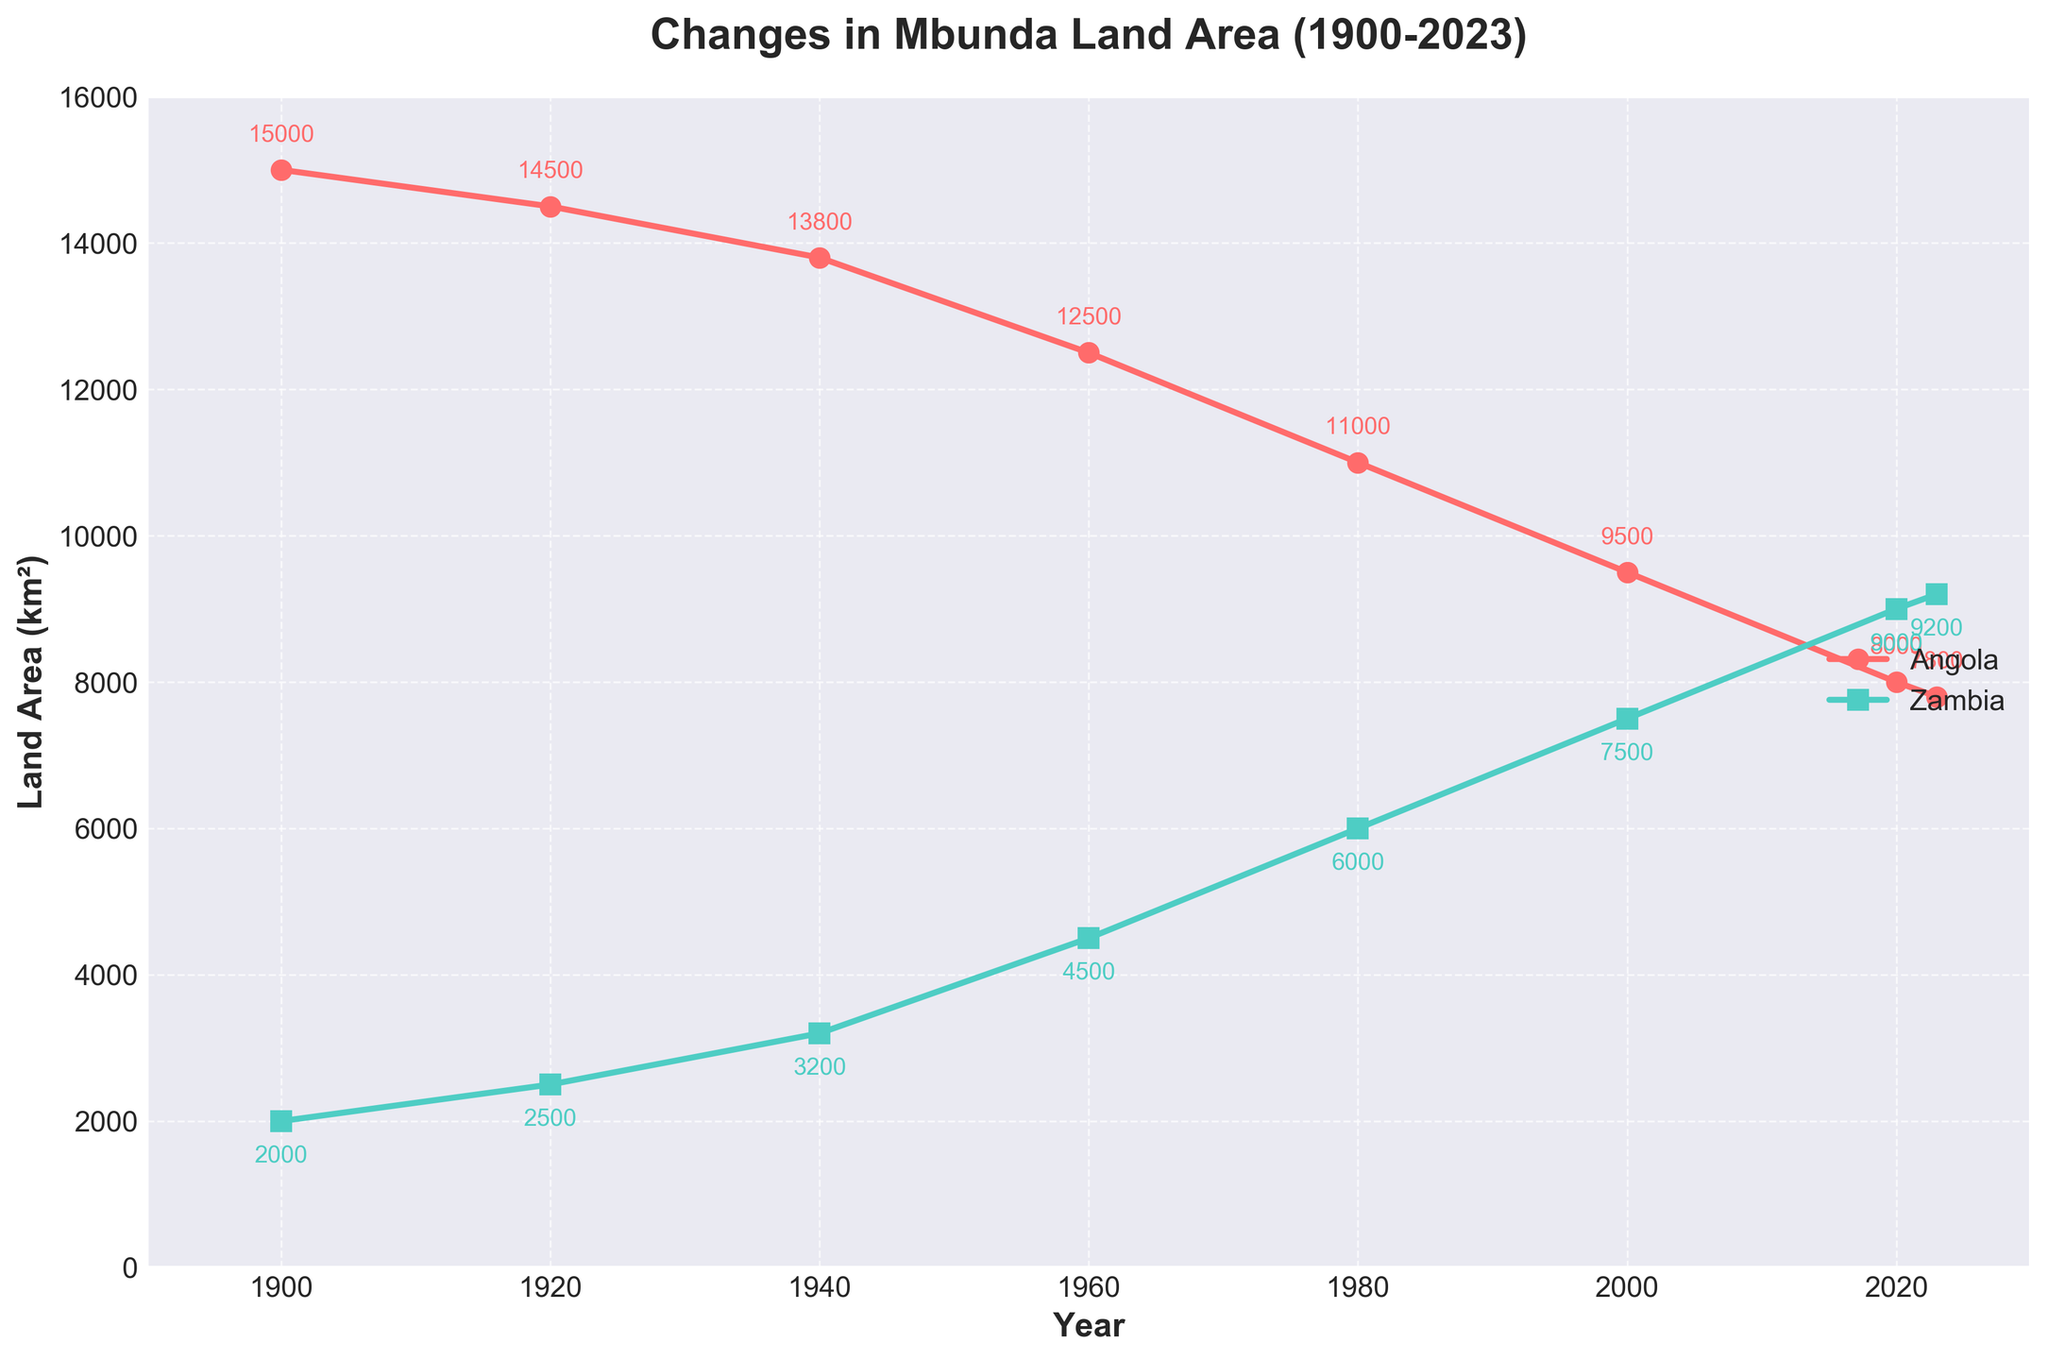What was the land area occupied by Mbunda communities in Angola in 1900? Look at the y-axis for the land area corresponding to the year 1900 along the x-axis for Angola's line (red).
Answer: 15,000 km² What trend do you observe for the land area occupied by the Mbunda community in Zambia from 1900 to 2023? Observe the green line on the plot from 1900 to 2023. It shows a consistent increase over time.
Answer: Increasing Which year did Angola's Mbunda community have a land area of 11,000 km²? Track the red line and find the point where it intersects with the 11,000 km² mark on the y-axis.
Answer: 1980 What is the difference in land area occupied by the Mbunda communities in Zambia between the years 1960 and 1980? On the green line, find the land areas for the years 1960 and 1980 and subtract the 1960 value from the 1980 value. 4500 km² and 6000 km² respectively. Thus, 6000 - 4500 = 1500.
Answer: 1,500 km² In which year did the Mbunda communities in Zambia first occupy a larger area than those in Angola? Compare the values of both lines (red and green) across years. Find the first year where the green line is above the red line.
Answer: 2020 How much land area did Mbunda communities lose in Angola from 1940 to 1980? For Angola, note the land areas from the red line at 1940 and 1980. Then, subtract the 1980 value from the 1940 value. 13800 km² and 11000 km² respectively. Thus, 13800 - 11000 = 2800.
Answer: 2,800 km² By how much did the land area occupied by Mbunda communities increase in Zambia from 1900 to 2023? Observe the change in the green line from 1900 to 2023. Subtract the 1900 value from the 2023 value. 9200 km² (2023) - 2000 km² (1900) = 7200 km²
Answer: 7,200 km² Which country had a more rapid decline in land area from 1960 to 2020? Compare the slopes of the red and green lines between 1960 and 2020. The red line shows a steeper decline. Angola's decline from 12500 km² to 8000 km² (decline of 4500 km²) contrasts with Zambia's increase in the same period.
Answer: Angola How many years did it take for Zambia's Mbunda community to increase their land area from 2000 km² to 9000 km²? Identify the years for the respective land areas on the green line and calculate the duration. 2020 (9000 km²) - 1900 (2000 km²) = 120 years.
Answer: 120 years In 1920, what was the absolute difference in land area occupied by Mbunda communities between Angola and Zambia? Find both values for the year 1920 on the plot for Angola and Zambia (14500 km² and 2500 km² respectively). Then, subtract the Zambia value from the Angola value. 14500 - 2500 = 12000.
Answer: 12,000 km² 